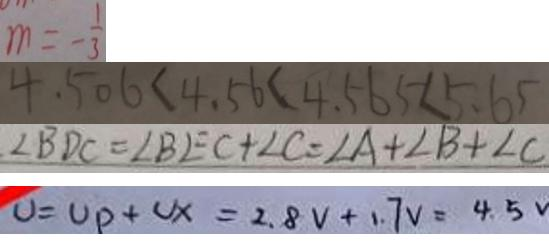<formula> <loc_0><loc_0><loc_500><loc_500>m = - \frac { 1 } { 3 } 
 4 . 5 0 6 < 4 . 5 6 < 4 . 5 6 5 < 5 . 6 5 
 \angle B D C = \angle B E C + \angle C = \angle A + \angle B + \angle C 
 U = U p + U x = 2 . 8 V + 1 . 7 v = 4 . 5 V</formula> 